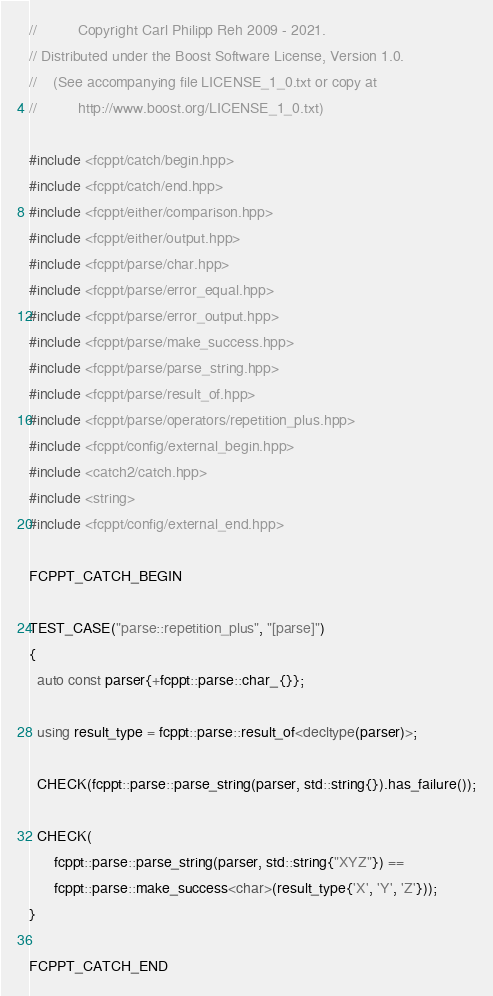Convert code to text. <code><loc_0><loc_0><loc_500><loc_500><_C++_>//          Copyright Carl Philipp Reh 2009 - 2021.
// Distributed under the Boost Software License, Version 1.0.
//    (See accompanying file LICENSE_1_0.txt or copy at
//          http://www.boost.org/LICENSE_1_0.txt)

#include <fcppt/catch/begin.hpp>
#include <fcppt/catch/end.hpp>
#include <fcppt/either/comparison.hpp>
#include <fcppt/either/output.hpp>
#include <fcppt/parse/char.hpp>
#include <fcppt/parse/error_equal.hpp>
#include <fcppt/parse/error_output.hpp>
#include <fcppt/parse/make_success.hpp>
#include <fcppt/parse/parse_string.hpp>
#include <fcppt/parse/result_of.hpp>
#include <fcppt/parse/operators/repetition_plus.hpp>
#include <fcppt/config/external_begin.hpp>
#include <catch2/catch.hpp>
#include <string>
#include <fcppt/config/external_end.hpp>

FCPPT_CATCH_BEGIN

TEST_CASE("parse::repetition_plus", "[parse]")
{
  auto const parser{+fcppt::parse::char_{}};

  using result_type = fcppt::parse::result_of<decltype(parser)>;

  CHECK(fcppt::parse::parse_string(parser, std::string{}).has_failure());

  CHECK(
      fcppt::parse::parse_string(parser, std::string{"XYZ"}) ==
      fcppt::parse::make_success<char>(result_type{'X', 'Y', 'Z'}));
}

FCPPT_CATCH_END
</code> 